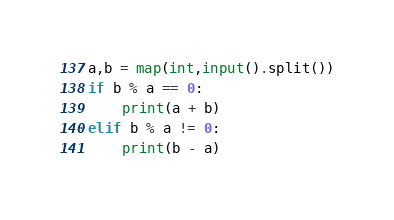<code> <loc_0><loc_0><loc_500><loc_500><_Python_>a,b = map(int,input().split())
if b % a == 0:
    print(a + b)
elif b % a != 0:
    print(b - a)</code> 